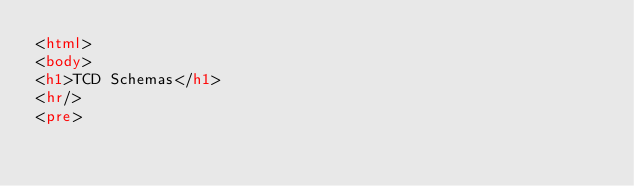<code> <loc_0><loc_0><loc_500><loc_500><_HTML_><html>
<body>
<h1>TCD Schemas</h1>
<hr/>
<pre></code> 